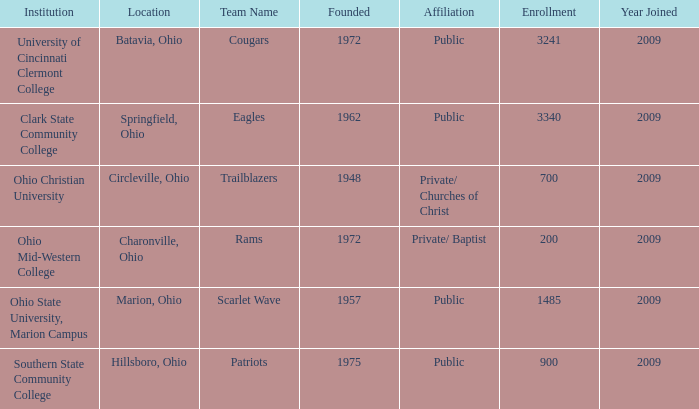In which place was the team name "patriots" established? Hillsboro, Ohio. 